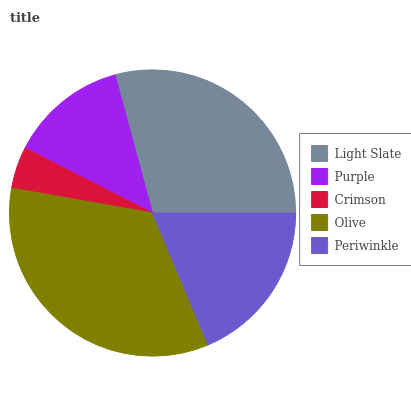Is Crimson the minimum?
Answer yes or no. Yes. Is Olive the maximum?
Answer yes or no. Yes. Is Purple the minimum?
Answer yes or no. No. Is Purple the maximum?
Answer yes or no. No. Is Light Slate greater than Purple?
Answer yes or no. Yes. Is Purple less than Light Slate?
Answer yes or no. Yes. Is Purple greater than Light Slate?
Answer yes or no. No. Is Light Slate less than Purple?
Answer yes or no. No. Is Periwinkle the high median?
Answer yes or no. Yes. Is Periwinkle the low median?
Answer yes or no. Yes. Is Purple the high median?
Answer yes or no. No. Is Light Slate the low median?
Answer yes or no. No. 